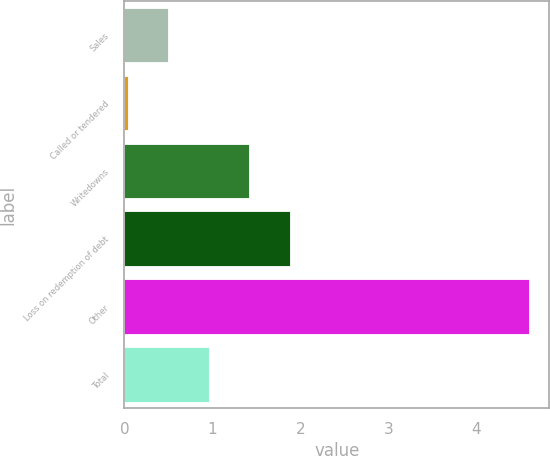<chart> <loc_0><loc_0><loc_500><loc_500><bar_chart><fcel>Sales<fcel>Called or tendered<fcel>Writedowns<fcel>Loss on redemption of debt<fcel>Other<fcel>Total<nl><fcel>0.5<fcel>0.04<fcel>1.42<fcel>1.88<fcel>4.6<fcel>0.96<nl></chart> 